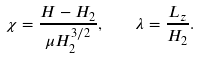Convert formula to latex. <formula><loc_0><loc_0><loc_500><loc_500>\chi = \frac { H - H _ { 2 } } { \mu H _ { 2 } ^ { 3 / 2 } } , \quad \lambda = \frac { L _ { z } } { H _ { 2 } } .</formula> 